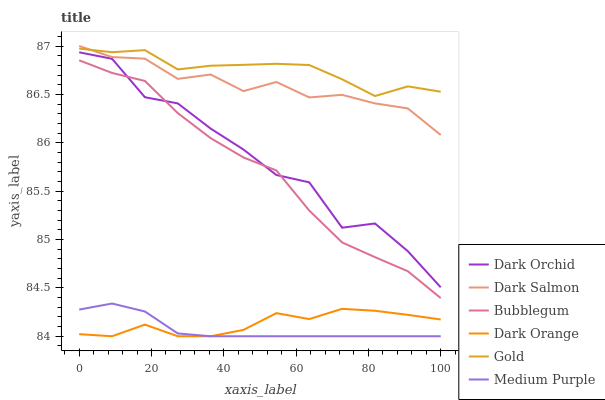Does Medium Purple have the minimum area under the curve?
Answer yes or no. Yes. Does Gold have the maximum area under the curve?
Answer yes or no. Yes. Does Dark Salmon have the minimum area under the curve?
Answer yes or no. No. Does Dark Salmon have the maximum area under the curve?
Answer yes or no. No. Is Medium Purple the smoothest?
Answer yes or no. Yes. Is Dark Orchid the roughest?
Answer yes or no. Yes. Is Gold the smoothest?
Answer yes or no. No. Is Gold the roughest?
Answer yes or no. No. Does Dark Orange have the lowest value?
Answer yes or no. Yes. Does Dark Salmon have the lowest value?
Answer yes or no. No. Does Dark Salmon have the highest value?
Answer yes or no. Yes. Does Gold have the highest value?
Answer yes or no. No. Is Medium Purple less than Dark Orchid?
Answer yes or no. Yes. Is Dark Salmon greater than Dark Orange?
Answer yes or no. Yes. Does Dark Orchid intersect Bubblegum?
Answer yes or no. Yes. Is Dark Orchid less than Bubblegum?
Answer yes or no. No. Is Dark Orchid greater than Bubblegum?
Answer yes or no. No. Does Medium Purple intersect Dark Orchid?
Answer yes or no. No. 